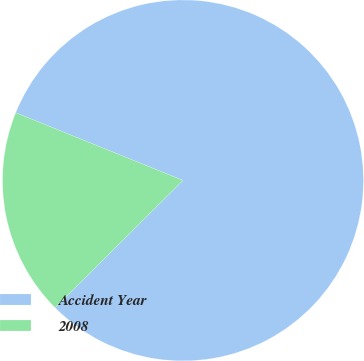Convert chart. <chart><loc_0><loc_0><loc_500><loc_500><pie_chart><fcel>Accident Year<fcel>2008<nl><fcel>81.42%<fcel>18.58%<nl></chart> 